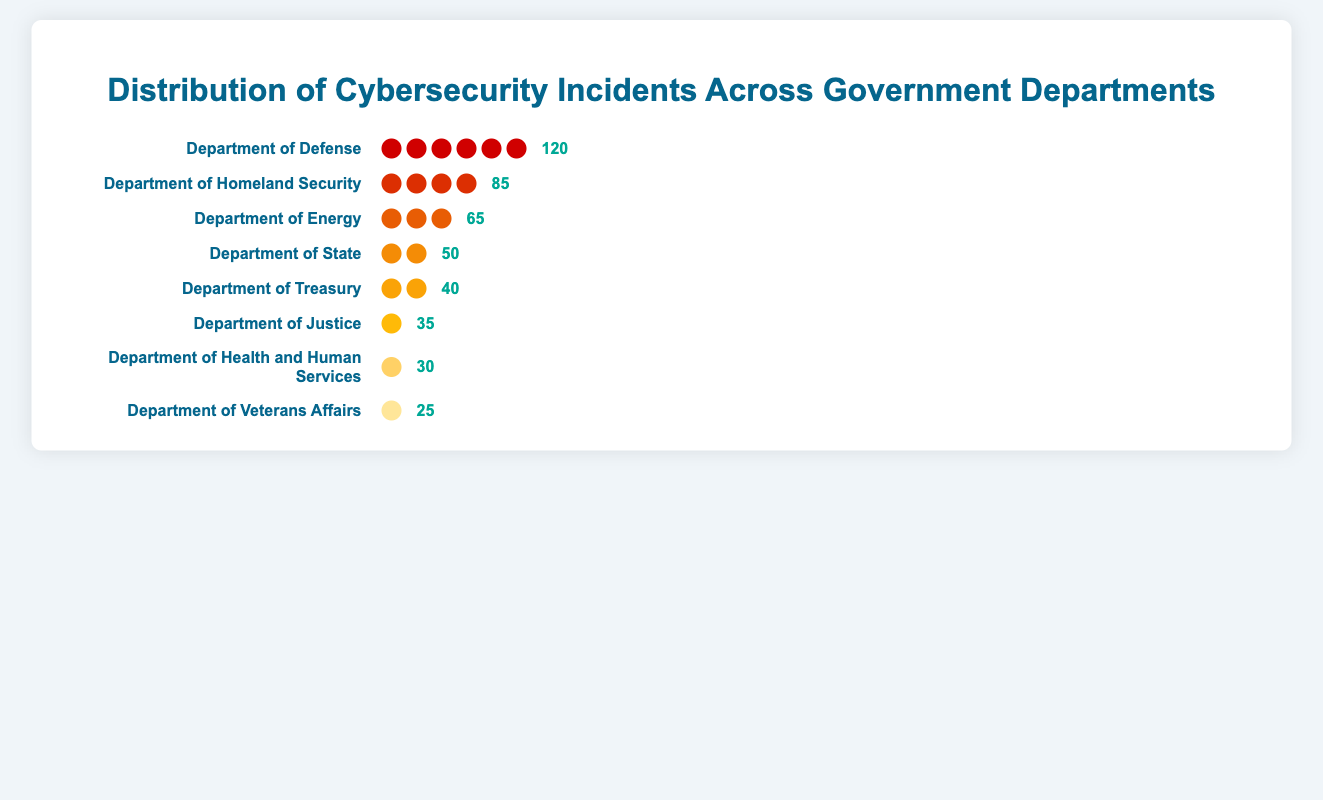How many incidents did the Department of Defense have? The Department of Defense's incidents are displayed as a series of icons next to its name. Counting the icons will give the total number of incidents. Each icon represents a certain number of incidents. Additionally, the number is displayed to the right of the icons.
Answer: 120 Which department experienced the fewest cybersecurity incidents? The chart shows different cybersecurity incident counts for various departments. The department with the fewest incidents will have the least number of icons and the smallest number displayed next to it.
Answer: Department of Veterans Affairs How many more incidents did the Department of Homeland Security have compared to the Department of Treasury? The Department of Homeland Security had 85 incidents and the Department of Treasury had 40 incidents. Subtract the number of incidents for the Treasury from Homeland Security's incidents.
Answer: 45 Which department had the second-highest number of incidents? The highest number belongs to the Department of Defense with 120 incidents. The next highest number visible on the chart will be the second highest. The Department of Homeland Security has the second-highest number of incidents with 85.
Answer: Department of Homeland Security What is the total number of incidents across all the departments? Sum the number of incidents listed for each department: 120 (Defense) + 85 (Homeland Security) + 65 (Energy) + 50 (State) + 40 (Treasury) + 35 (Justice) + 30 (Health and Human Services) + 25 (Veterans Affairs).
Answer: 450 How many departments experienced fewer than 40 incidents? By checking the individual counts displayed next to each department name, identify which ones have fewer than 40 incidents: Department of Justice (35), Department of Health and Human Services (30), Department of Veterans Affairs (25).
Answer: 3 Compare the total incidents of the Department of Veterans Affairs and the Department of Health and Human Services. Which had more incidents? The Department of Health and Human Services had 30 incidents, and the Department of Veterans Affairs had 25 incidents. Comparing these numbers shows that Health and Human Services had more incidents.
Answer: Department of Health and Human Services What proportion of total incidents did the Department of Energy's incidents represent? Calculate the total number of incidents: 450. The Department of Energy had 65 incidents. Divide the Department of Energy's incidents by the total number of incidents and convert to a percentage: (65/450) * 100.
Answer: 14.4% If the Department of Defense reduced their incidents by 20%, how many incidents would they have? Calculate 20% of 120 incidents for the Department of Defense: 
20% of 120 is 0.2 * 120 = 24. Subtract 24 from 120.
Answer: 96 Which two departments have a combined incident count closest to 100? Compare combinations of two departments' incident counts: Department of Energy (65) + Department of State (50) = 115, Department of Treasury (40) + Department of Homeland Security (85) = 125. The closest would be Department of Energy (65) and Department of State (50).
Answer: Department of Energy and Department of State 